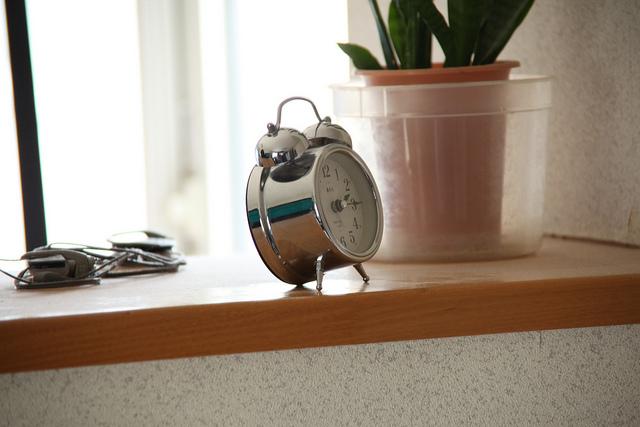What color is the block on the counter?
Answer briefly. Silver. What kind of clock is it?
Write a very short answer. Alarm. What time does the clock say?
Short answer required. 2:15. What is the time?
Short answer required. 2:15. 